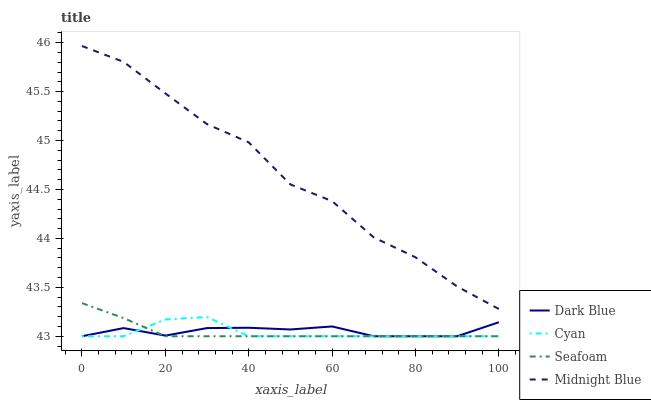Does Midnight Blue have the minimum area under the curve?
Answer yes or no. No. Does Seafoam have the maximum area under the curve?
Answer yes or no. No. Is Midnight Blue the smoothest?
Answer yes or no. No. Is Seafoam the roughest?
Answer yes or no. No. Does Midnight Blue have the lowest value?
Answer yes or no. No. Does Seafoam have the highest value?
Answer yes or no. No. Is Cyan less than Midnight Blue?
Answer yes or no. Yes. Is Midnight Blue greater than Dark Blue?
Answer yes or no. Yes. Does Cyan intersect Midnight Blue?
Answer yes or no. No. 